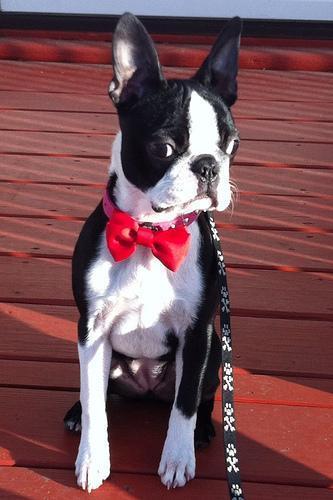How many dog's are in the picture?
Give a very brief answer. 1. 